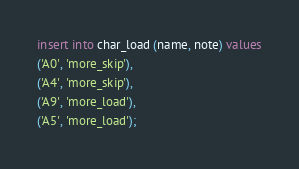Convert code to text. <code><loc_0><loc_0><loc_500><loc_500><_SQL_>
insert into char_load (name, note) values
('A0', 'more_skip'),
('A4', 'more_skip'),
('A9', 'more_load'),
('A5', 'more_load');

</code> 